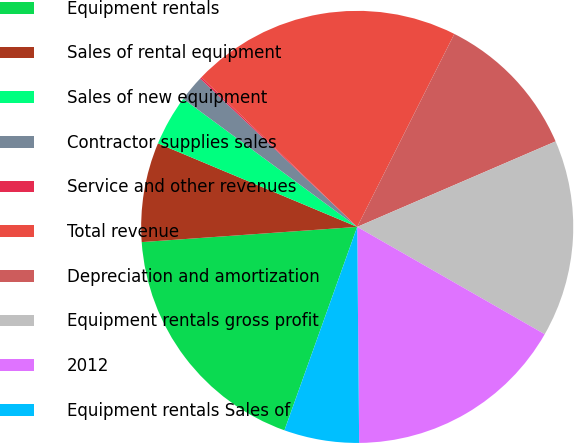Convert chart. <chart><loc_0><loc_0><loc_500><loc_500><pie_chart><fcel>Equipment rentals<fcel>Sales of rental equipment<fcel>Sales of new equipment<fcel>Contractor supplies sales<fcel>Service and other revenues<fcel>Total revenue<fcel>Depreciation and amortization<fcel>Equipment rentals gross profit<fcel>2012<fcel>Equipment rentals Sales of<nl><fcel>18.41%<fcel>7.44%<fcel>3.78%<fcel>1.95%<fcel>0.13%<fcel>20.24%<fcel>11.1%<fcel>14.75%<fcel>16.58%<fcel>5.61%<nl></chart> 